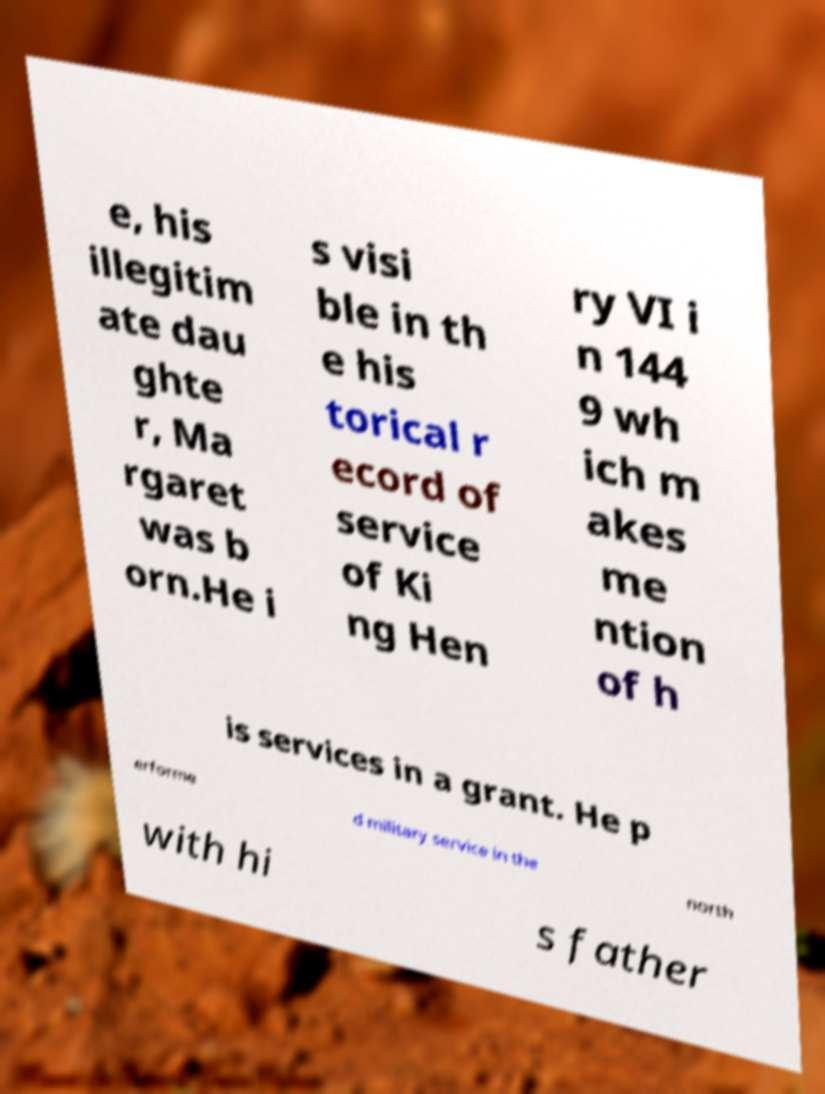Can you read and provide the text displayed in the image?This photo seems to have some interesting text. Can you extract and type it out for me? e, his illegitim ate dau ghte r, Ma rgaret was b orn.He i s visi ble in th e his torical r ecord of service of Ki ng Hen ry VI i n 144 9 wh ich m akes me ntion of h is services in a grant. He p erforme d military service in the north with hi s father 